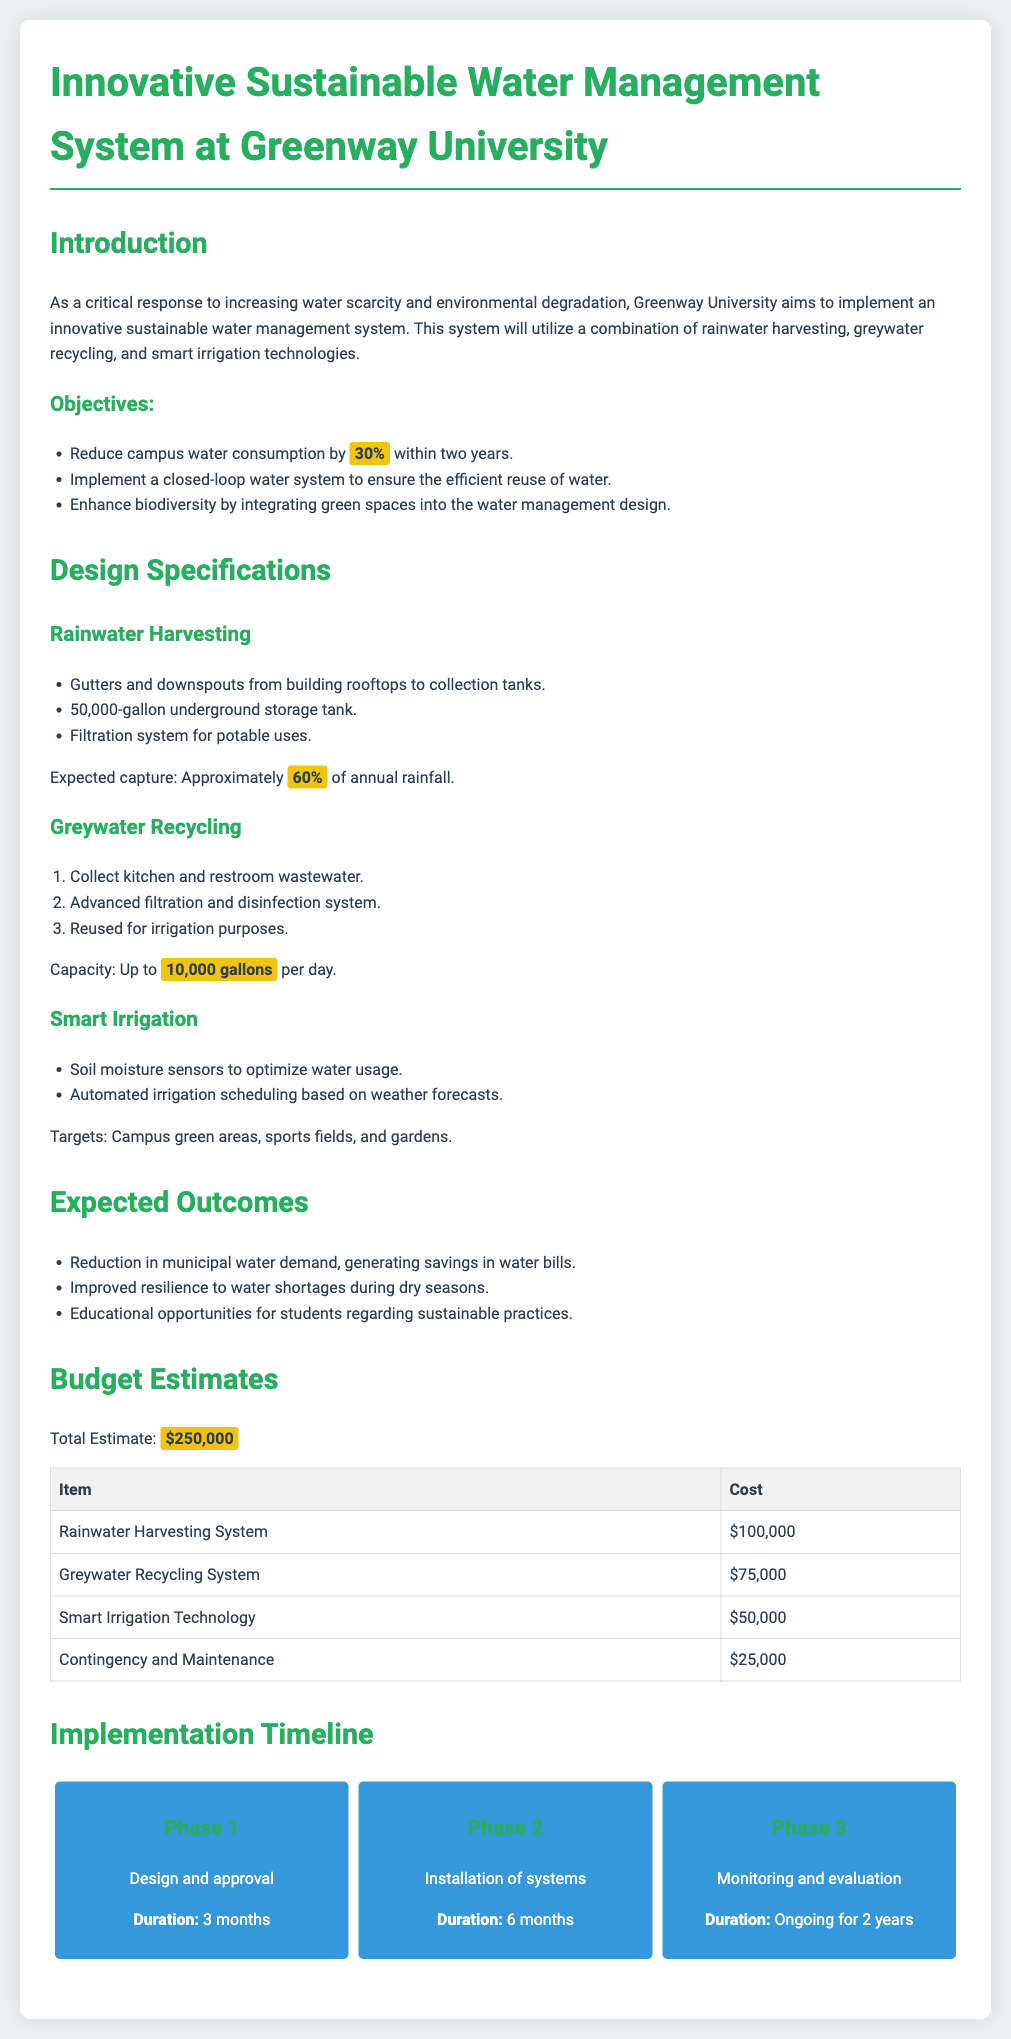what is the total cost estimate of the project? The total cost estimate is listed as the sum of the various components of the project, which is $250,000.
Answer: $250,000 how much rainwater is expected to be captured? The document states that approximately 60% of annual rainfall is expected to be captured through the rainwater harvesting system.
Answer: 60% what is the capacity for greywater recycling per day? The capacity for greywater recycling is indicated in the document as up to 10,000 gallons per day.
Answer: 10,000 gallons what are the three main components of the water management system? The three main components of the proposed system are outlined in the introduction, which includes rainwater harvesting, greywater recycling, and smart irrigation technologies.
Answer: Rainwater harvesting, greywater recycling, smart irrigation what is the duration for Phase 2 of implementation? The duration for Phase 2, which involves the installation of systems, is specified in the timeline section as 6 months.
Answer: 6 months which component has the highest estimated cost? The highest estimated cost among the components is for the rainwater harvesting system, listed at $100,000.
Answer: Rainwater Harvesting System how many phases are there in the implementation timeline? The implementation timeline is divided into three distinct phases, as outlined in the document.
Answer: 3 what is the goal for reducing campus water consumption? The goal for reducing campus water consumption is explicitly mentioned as reducing it by 30% within two years.
Answer: 30% which phase involves monitoring and evaluation? Monitoring and evaluation is included in Phase 3 of the implementation timeline as noted in the document.
Answer: Phase 3 